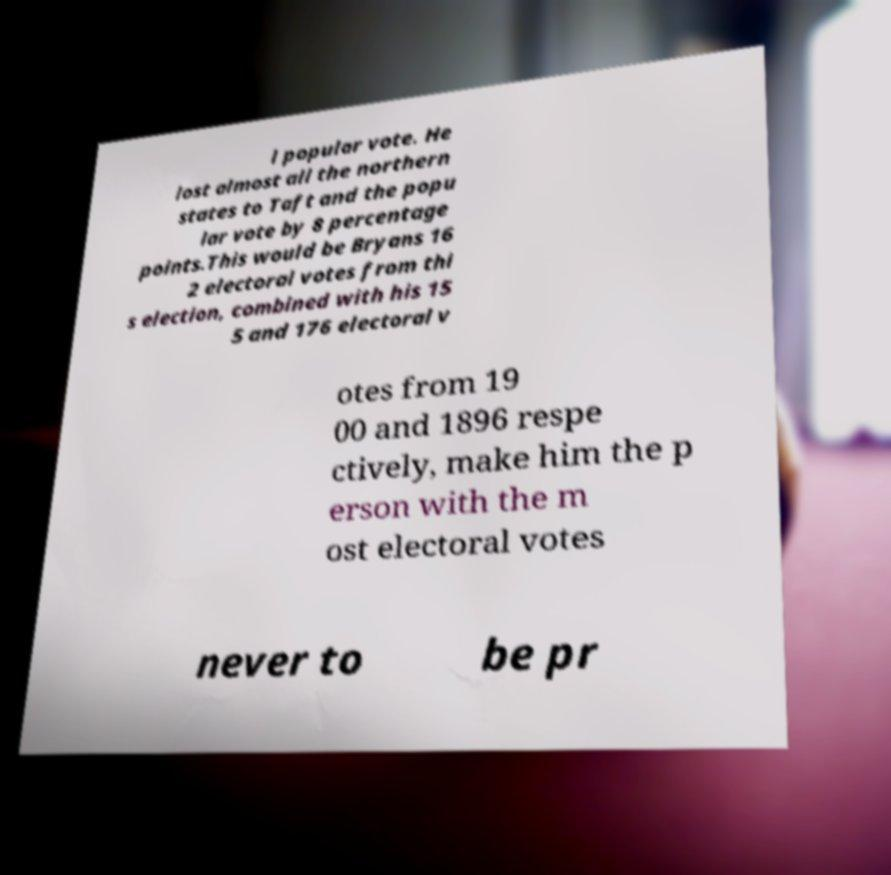Could you extract and type out the text from this image? l popular vote. He lost almost all the northern states to Taft and the popu lar vote by 8 percentage points.This would be Bryans 16 2 electoral votes from thi s election, combined with his 15 5 and 176 electoral v otes from 19 00 and 1896 respe ctively, make him the p erson with the m ost electoral votes never to be pr 